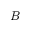Convert formula to latex. <formula><loc_0><loc_0><loc_500><loc_500>B</formula> 